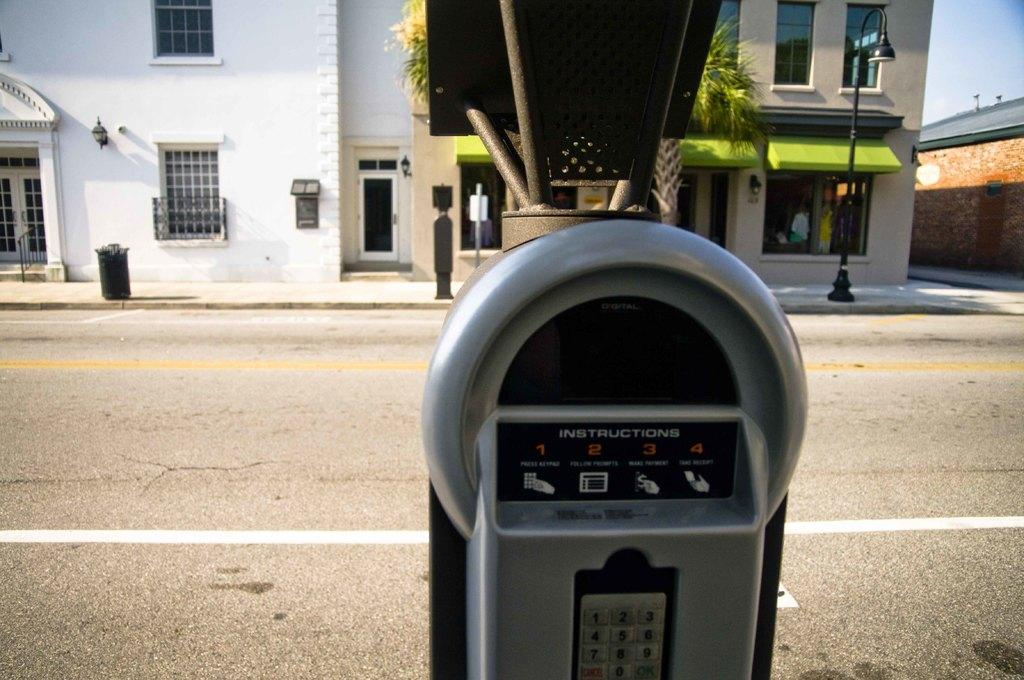<image>
Offer a succinct explanation of the picture presented. The parking meter has four step sequence in the instructions. 